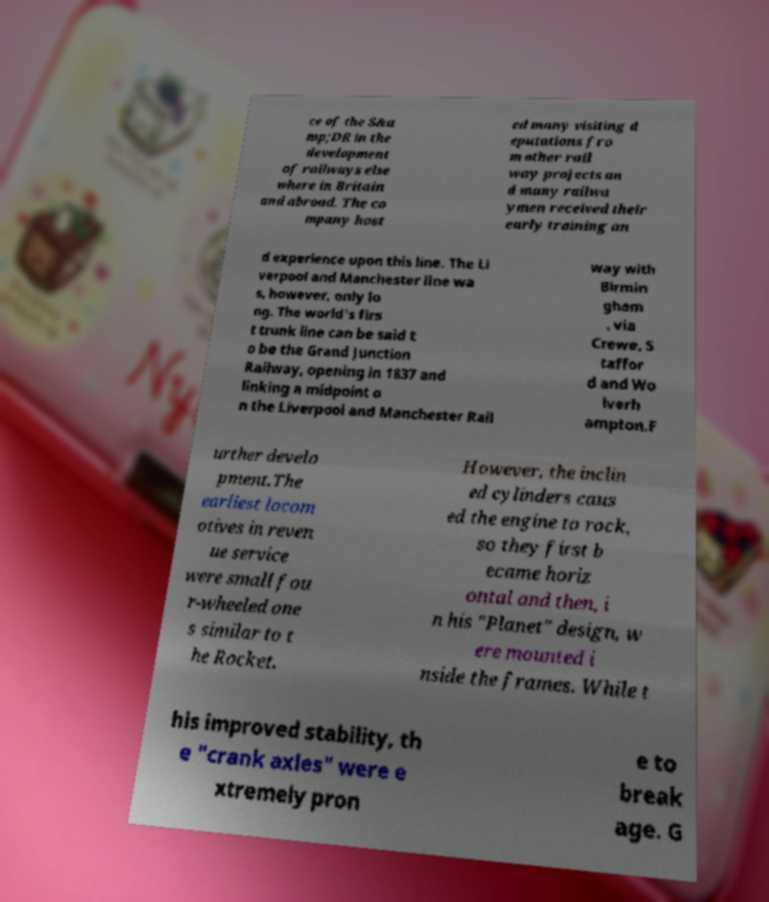Can you accurately transcribe the text from the provided image for me? ce of the S&a mp;DR in the development of railways else where in Britain and abroad. The co mpany host ed many visiting d eputations fro m other rail way projects an d many railwa ymen received their early training an d experience upon this line. The Li verpool and Manchester line wa s, however, only lo ng. The world's firs t trunk line can be said t o be the Grand Junction Railway, opening in 1837 and linking a midpoint o n the Liverpool and Manchester Rail way with Birmin gham , via Crewe, S taffor d and Wo lverh ampton.F urther develo pment.The earliest locom otives in reven ue service were small fou r-wheeled one s similar to t he Rocket. However, the inclin ed cylinders caus ed the engine to rock, so they first b ecame horiz ontal and then, i n his "Planet" design, w ere mounted i nside the frames. While t his improved stability, th e "crank axles" were e xtremely pron e to break age. G 